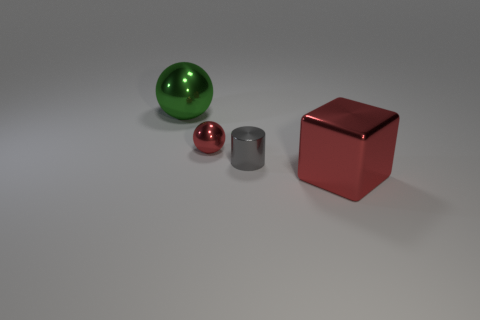Subtract all red spheres. How many spheres are left? 1 Subtract 1 spheres. How many spheres are left? 1 Subtract all cylinders. How many objects are left? 3 Subtract all gray spheres. How many green cylinders are left? 0 Add 1 large cyan blocks. How many objects exist? 5 Add 3 green spheres. How many green spheres are left? 4 Add 2 cyan shiny cylinders. How many cyan shiny cylinders exist? 2 Subtract 0 cyan blocks. How many objects are left? 4 Subtract all purple blocks. Subtract all purple cylinders. How many blocks are left? 1 Subtract all big gray matte blocks. Subtract all red things. How many objects are left? 2 